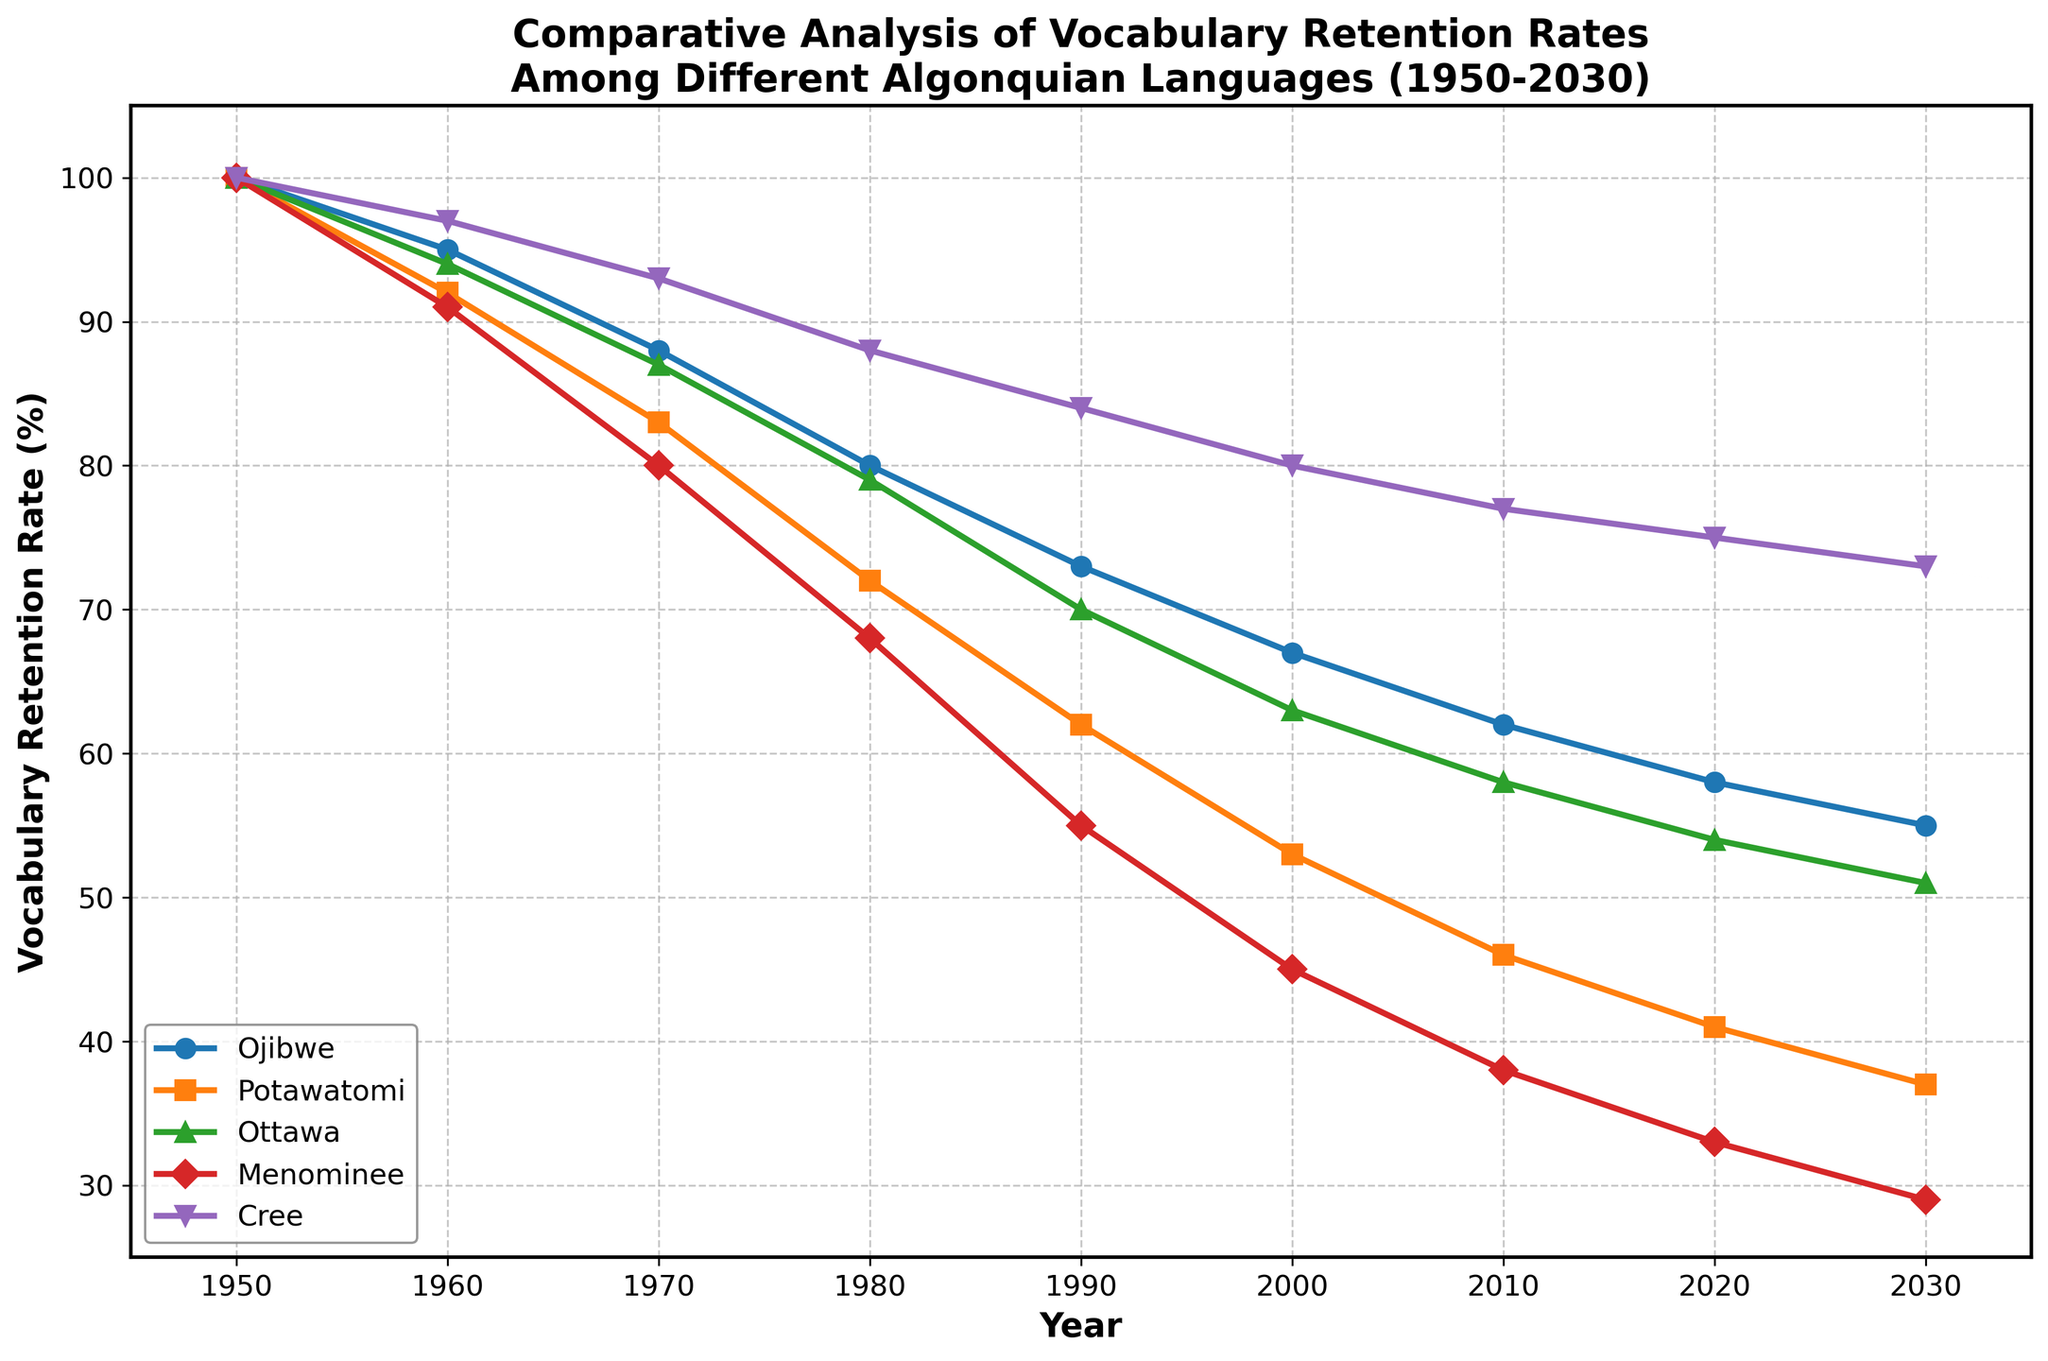What is the vocabulary retention rate of Ojibwe in 1970? To find this, refer to the Ojibwe line at the point corresponding to the year 1970 on the x-axis. The y-axis value at this point will indicate the vocabulary retention rate.
Answer: 88% Which language had the highest vocabulary retention rate in 2000 and what was it? Look at the y-axis values for all languages in the year 2000, and identify which line reaches the highest point.
Answer: Cree, 80% What is the difference in vocabulary retention rates between Potawatomi and Ottawa in 1990? Find the y-axis values for Potawatomi and Ottawa in 1990 and subtract the Ottawa value from the Potawatomi value: 62 - 70.
Answer: -8 Which language shows the steepest decline in vocabulary retention from 1950 to 2030? Determine which language has the highest absolute decrease from 1950 to 2030 by comparing the retention rates for each language at these two time points.
Answer: Menominee By how many percentage points did Menominee's vocabulary retention rate decrease from 1950 to 1980? Find the y-axis values for Menominee in 1950 and 1980, and subtract the 1980 value from the 1950 value: 100 - 68.
Answer: 32 Which language had the smallest decrease in vocabulary retention rate from 1950 to 2030? Compare the difference in retention rates from 1950 to 2030 for all languages; the language with the smallest value indicates the smallest decrease.
Answer: Cree What was the trend in vocabulary retention for Potawatomi and Ottawa from 1980 to 2010? Observe the lines for Potawatomi and Ottawa between 1980 and 2010. Identify whether the lines generally decrease, increase, or stay the same.
Answer: Both decrease Among the five languages, which one remained consistently above 70% retention rate until 1990? Examine each of the lines on the plot to see which one stays above the 70% mark until 1990.
Answer: Cree 